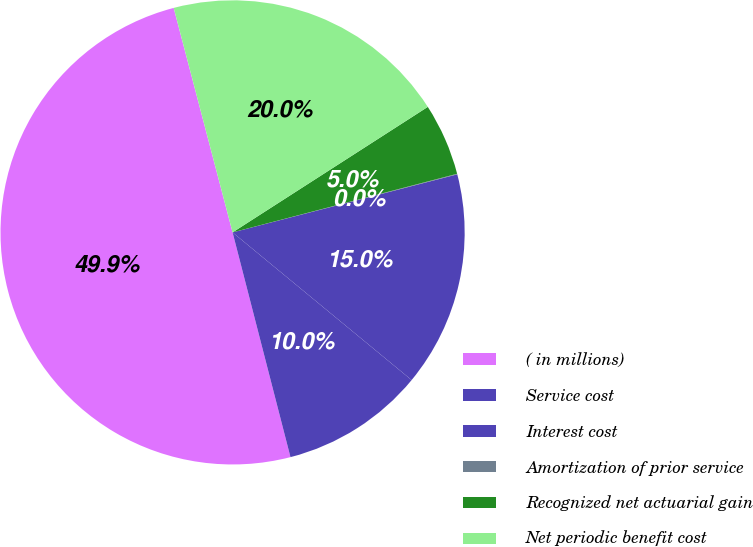Convert chart to OTSL. <chart><loc_0><loc_0><loc_500><loc_500><pie_chart><fcel>( in millions)<fcel>Service cost<fcel>Interest cost<fcel>Amortization of prior service<fcel>Recognized net actuarial gain<fcel>Net periodic benefit cost<nl><fcel>49.93%<fcel>10.01%<fcel>15.0%<fcel>0.04%<fcel>5.03%<fcel>19.99%<nl></chart> 